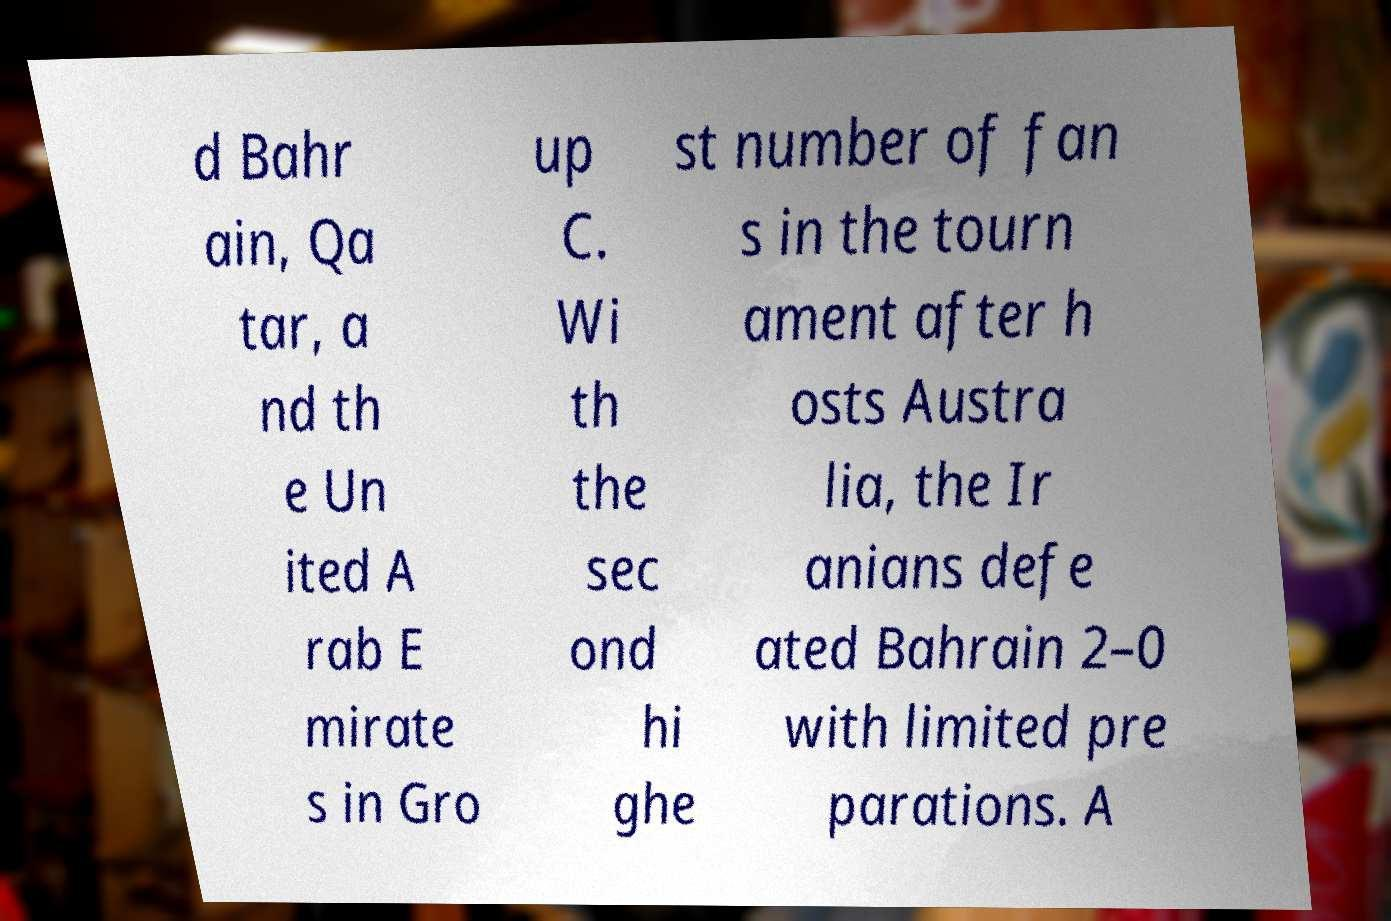Can you accurately transcribe the text from the provided image for me? d Bahr ain, Qa tar, a nd th e Un ited A rab E mirate s in Gro up C. Wi th the sec ond hi ghe st number of fan s in the tourn ament after h osts Austra lia, the Ir anians defe ated Bahrain 2–0 with limited pre parations. A 